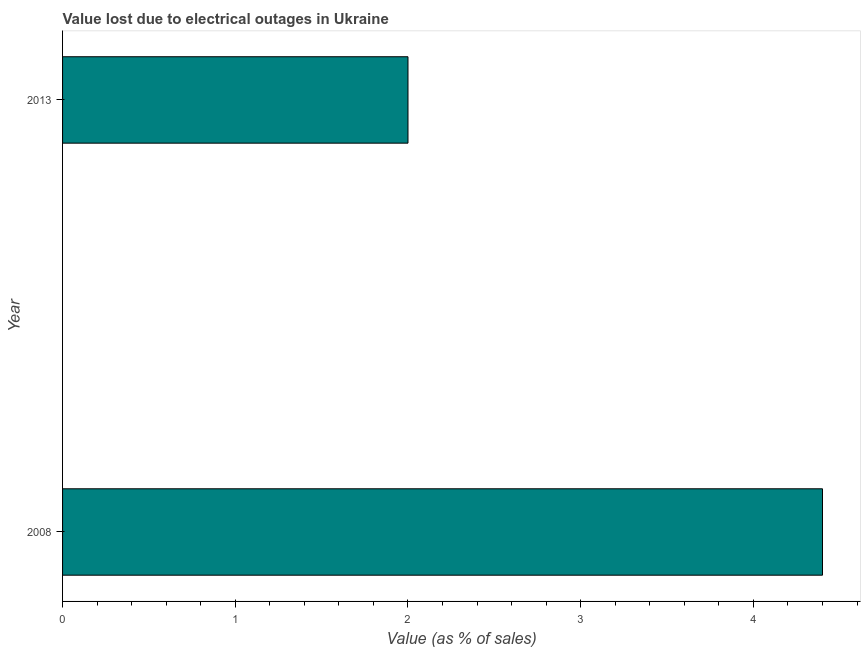Does the graph contain grids?
Your answer should be compact. No. What is the title of the graph?
Keep it short and to the point. Value lost due to electrical outages in Ukraine. What is the label or title of the X-axis?
Give a very brief answer. Value (as % of sales). What is the value lost due to electrical outages in 2008?
Keep it short and to the point. 4.4. Across all years, what is the maximum value lost due to electrical outages?
Provide a short and direct response. 4.4. In which year was the value lost due to electrical outages maximum?
Offer a very short reply. 2008. In which year was the value lost due to electrical outages minimum?
Give a very brief answer. 2013. What is the difference between the value lost due to electrical outages in 2008 and 2013?
Offer a terse response. 2.4. What is the median value lost due to electrical outages?
Provide a short and direct response. 3.2. In how many years, is the value lost due to electrical outages greater than 0.2 %?
Provide a short and direct response. 2. How many bars are there?
Ensure brevity in your answer.  2. Are all the bars in the graph horizontal?
Your answer should be compact. Yes. Are the values on the major ticks of X-axis written in scientific E-notation?
Keep it short and to the point. No. What is the Value (as % of sales) of 2008?
Your answer should be compact. 4.4. What is the Value (as % of sales) of 2013?
Give a very brief answer. 2. What is the difference between the Value (as % of sales) in 2008 and 2013?
Offer a terse response. 2.4. 